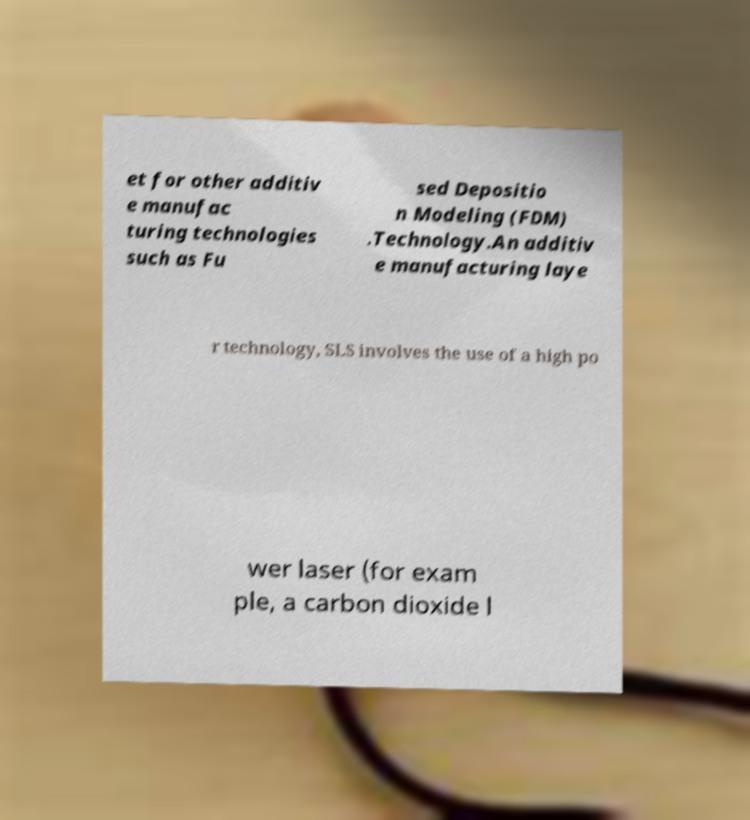For documentation purposes, I need the text within this image transcribed. Could you provide that? et for other additiv e manufac turing technologies such as Fu sed Depositio n Modeling (FDM) .Technology.An additiv e manufacturing laye r technology, SLS involves the use of a high po wer laser (for exam ple, a carbon dioxide l 